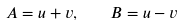<formula> <loc_0><loc_0><loc_500><loc_500>A = u + v , \quad B = u - v</formula> 